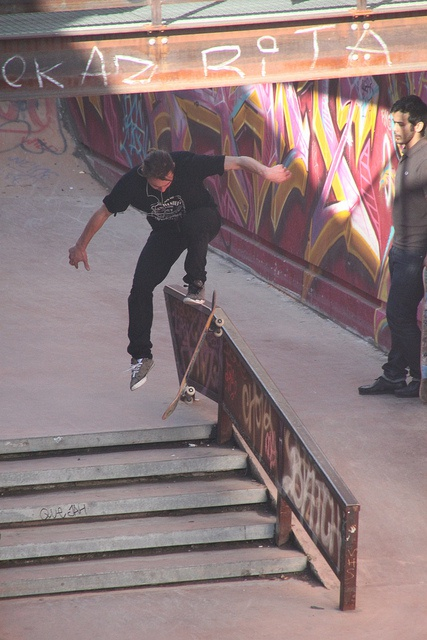Describe the objects in this image and their specific colors. I can see people in black, gray, and brown tones, people in black and gray tones, and skateboard in black, gray, and darkgray tones in this image. 